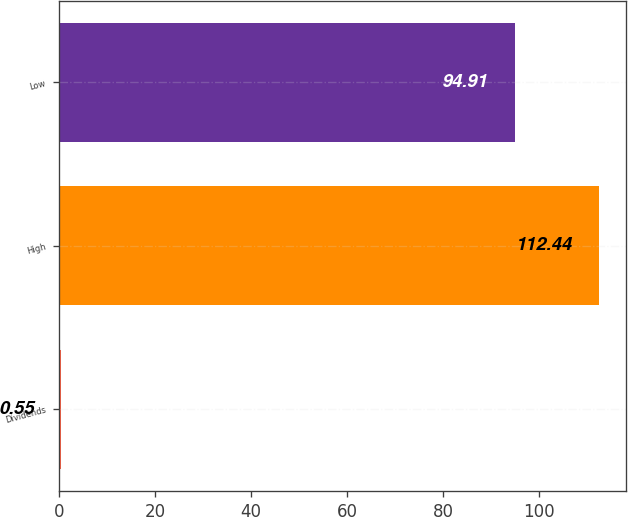<chart> <loc_0><loc_0><loc_500><loc_500><bar_chart><fcel>Dividends<fcel>High<fcel>Low<nl><fcel>0.55<fcel>112.44<fcel>94.91<nl></chart> 